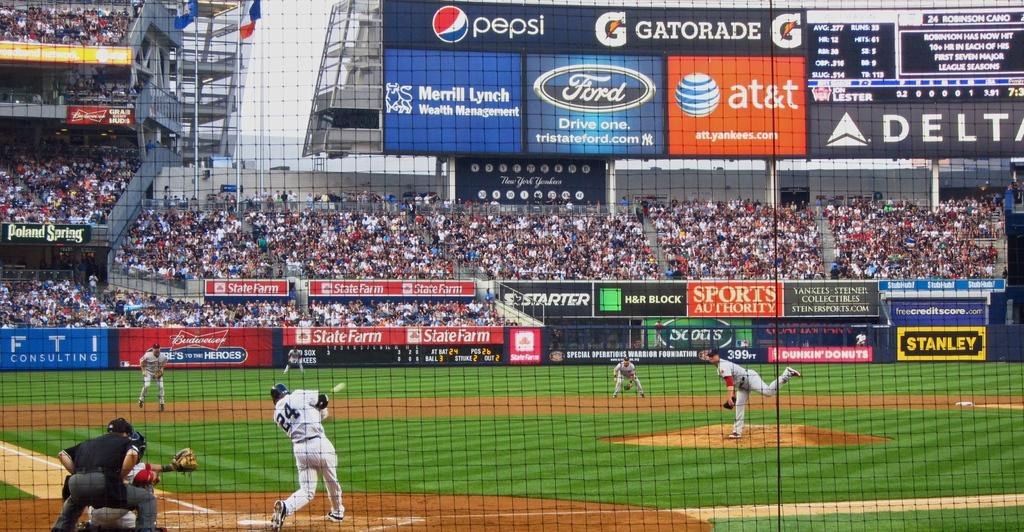<image>
Describe the image concisely. Robinson Cano bats for the Yankees against the Red Sox. 